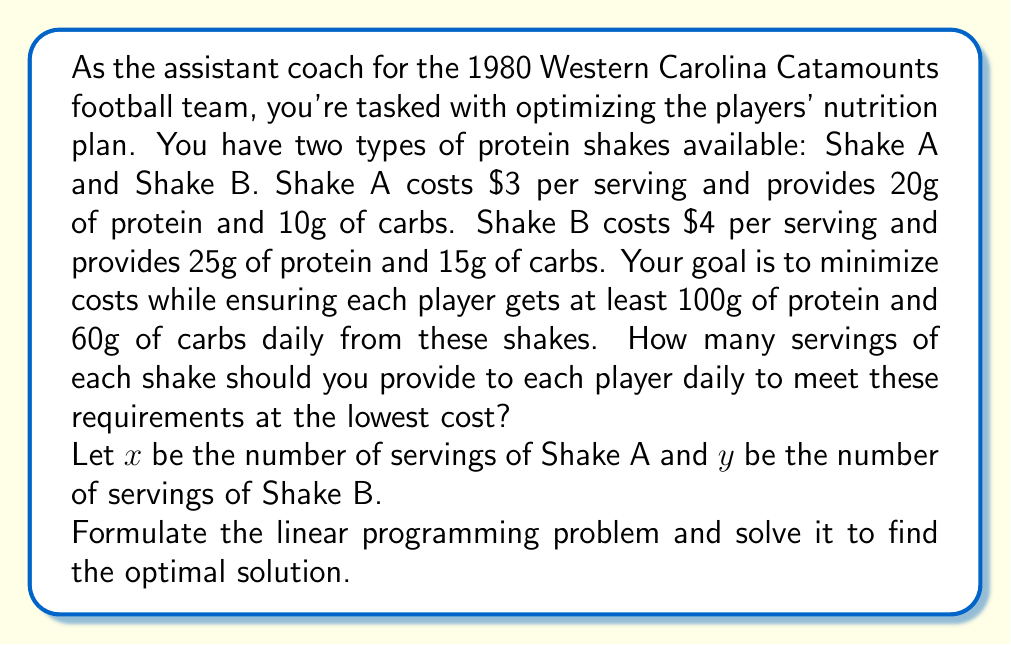Can you answer this question? Let's approach this step-by-step:

1) First, we need to formulate the objective function. We want to minimize the total cost:
   Minimize $Z = 3x + 4y$

2) Now, let's set up the constraints:
   For protein: $20x + 25y \geq 100$
   For carbs: $10x + 15y \geq 60$
   Non-negativity: $x \geq 0, y \geq 0$

3) We can solve this using the graphical method. Let's plot the constraints:

[asy]
size(200);
draw((0,0)--(10,0), arrow=Arrow);
draw((0,0)--(0,8), arrow=Arrow);
label("x", (10,0), E);
label("y", (0,8), N);

pen p = rgb(0,0,1)+1;
draw((0,4)--(5,0), p);
label("20x + 25y = 100", (5,0), SE);

pen q = rgb(1,0,0)+1;
draw((0,4)--(6,0), q);
label("10x + 15y = 60", (6,0), SE);

fill((0,4)--(5,0)--(0,0)--cycle, paleblue+opacity(0.1));

dot((2,2));
label("(2,2)", (2,2), NE);
[/asy]

4) The feasible region is the area above both constraint lines.

5) The optimal solution will be at one of the corner points of the feasible region. We need to check the point where the two constraint lines intersect.

6) To find this point, we solve the system of equations:
   $20x + 25y = 100$
   $10x + 15y = 60$

7) Multiplying the second equation by 2 and subtracting from the first:
   $20x + 25y = 100$
   $20x + 30y = 120$
   $-5y = -20$
   $y = 4$

8) Substituting this back into either equation:
   $20x + 25(4) = 100$
   $20x = 0$
   $x = 0$

9) So the point of intersection is (0, 4). However, we also need to check the y-intercepts:
   For the protein constraint: (0, 4)
   For the carb constraint: (0, 4)

10) Evaluating the objective function at (0, 4):
    $Z = 3(0) + 4(4) = 16$

This is the minimum cost solution that satisfies all constraints.
Answer: The optimal solution is to provide 0 servings of Shake A and 4 servings of Shake B daily to each player. This will cost $16 per player per day and provide 100g of protein and 60g of carbs, meeting the minimum requirements at the lowest cost. 